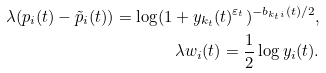Convert formula to latex. <formula><loc_0><loc_0><loc_500><loc_500>\lambda ( p _ { i } ( t ) - \tilde { p } _ { i } ( t ) ) = \log ( 1 + y _ { k _ { t } } ( t ) ^ { \varepsilon _ { t } } ) ^ { - b _ { k _ { t } i } ( t ) / 2 } , \\ \lambda w _ { i } ( t ) = \frac { 1 } { 2 } \log y _ { i } ( t ) .</formula> 